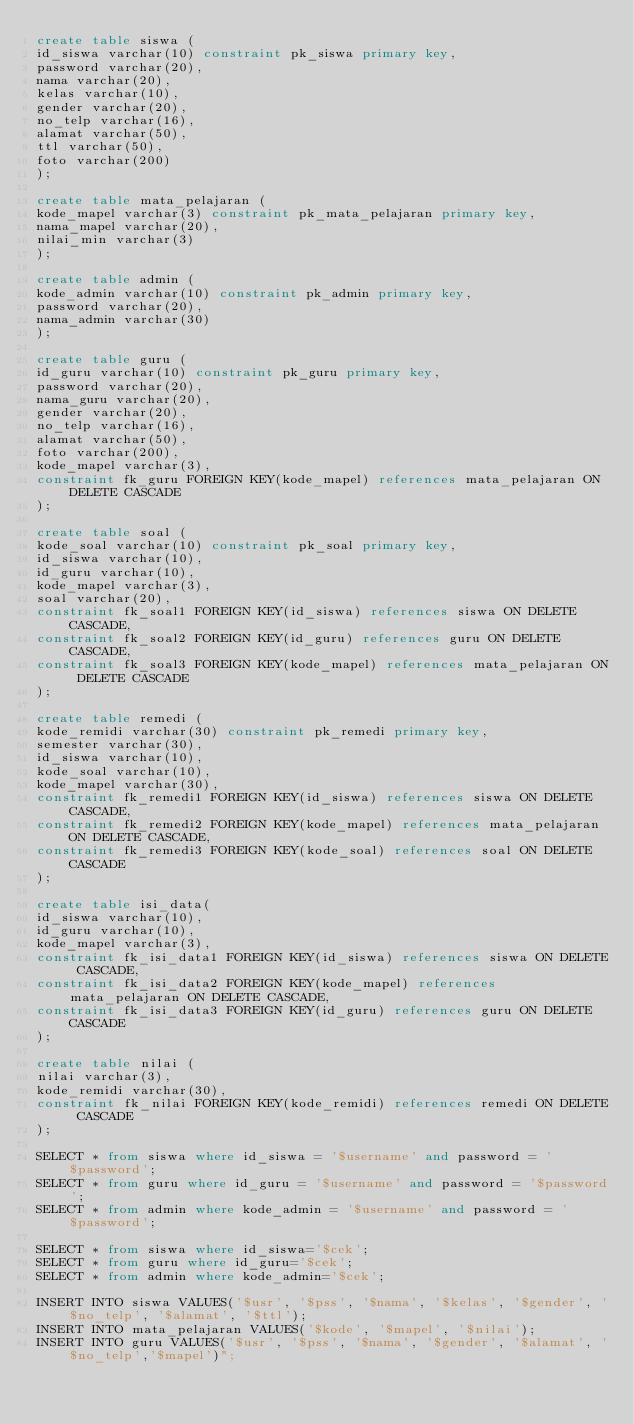Convert code to text. <code><loc_0><loc_0><loc_500><loc_500><_SQL_>create table siswa (
id_siswa varchar(10) constraint pk_siswa primary key,
password varchar(20),
nama varchar(20),
kelas varchar(10),
gender varchar(20),
no_telp varchar(16),
alamat varchar(50),
ttl varchar(50),
foto varchar(200)
);

create table mata_pelajaran (
kode_mapel varchar(3) constraint pk_mata_pelajaran primary key,
nama_mapel varchar(20),
nilai_min varchar(3)
);

create table admin (
kode_admin varchar(10) constraint pk_admin primary key,
password varchar(20),
nama_admin varchar(30)
);

create table guru (
id_guru varchar(10) constraint pk_guru primary key,
password varchar(20),
nama_guru varchar(20),
gender varchar(20),
no_telp varchar(16),
alamat varchar(50),
foto varchar(200),
kode_mapel varchar(3),
constraint fk_guru FOREIGN KEY(kode_mapel) references mata_pelajaran ON DELETE CASCADE
);

create table soal (
kode_soal varchar(10) constraint pk_soal primary key,
id_siswa varchar(10),
id_guru varchar(10),
kode_mapel varchar(3),
soal varchar(20),
constraint fk_soal1 FOREIGN KEY(id_siswa) references siswa ON DELETE CASCADE,
constraint fk_soal2 FOREIGN KEY(id_guru) references guru ON DELETE CASCADE,
constraint fk_soal3 FOREIGN KEY(kode_mapel) references mata_pelajaran ON DELETE CASCADE
);

create table remedi (
kode_remidi varchar(30) constraint pk_remedi primary key,
semester varchar(30),
id_siswa varchar(10),
kode_soal varchar(10),
kode_mapel varchar(30),
constraint fk_remedi1 FOREIGN KEY(id_siswa) references siswa ON DELETE CASCADE,
constraint fk_remedi2 FOREIGN KEY(kode_mapel) references mata_pelajaran ON DELETE CASCADE,
constraint fk_remedi3 FOREIGN KEY(kode_soal) references soal ON DELETE CASCADE
);

create table isi_data(
id_siswa varchar(10),
id_guru varchar(10),
kode_mapel varchar(3), 
constraint fk_isi_data1 FOREIGN KEY(id_siswa) references siswa ON DELETE CASCADE,
constraint fk_isi_data2 FOREIGN KEY(kode_mapel) references mata_pelajaran ON DELETE CASCADE,
constraint fk_isi_data3 FOREIGN KEY(id_guru) references guru ON DELETE CASCADE
);

create table nilai (
nilai varchar(3),
kode_remidi varchar(30),
constraint fk_nilai FOREIGN KEY(kode_remidi) references remedi ON DELETE CASCADE
);

SELECT * from siswa where id_siswa = '$username' and password = '$password';
SELECT * from guru where id_guru = '$username' and password = '$password';
SELECT * from admin where kode_admin = '$username' and password = '$password';

SELECT * from siswa where id_siswa='$cek';
SELECT * from guru where id_guru='$cek';
SELECT * from admin where kode_admin='$cek';

INSERT INTO siswa VALUES('$usr', '$pss', '$nama', '$kelas', '$gender', '$no_telp', '$alamat', '$ttl');
INSERT INTO mata_pelajaran VALUES('$kode', '$mapel', '$nilai');
INSERT INTO guru VALUES('$usr', '$pss', '$nama', '$gender', '$alamat', '$no_telp','$mapel')";</code> 